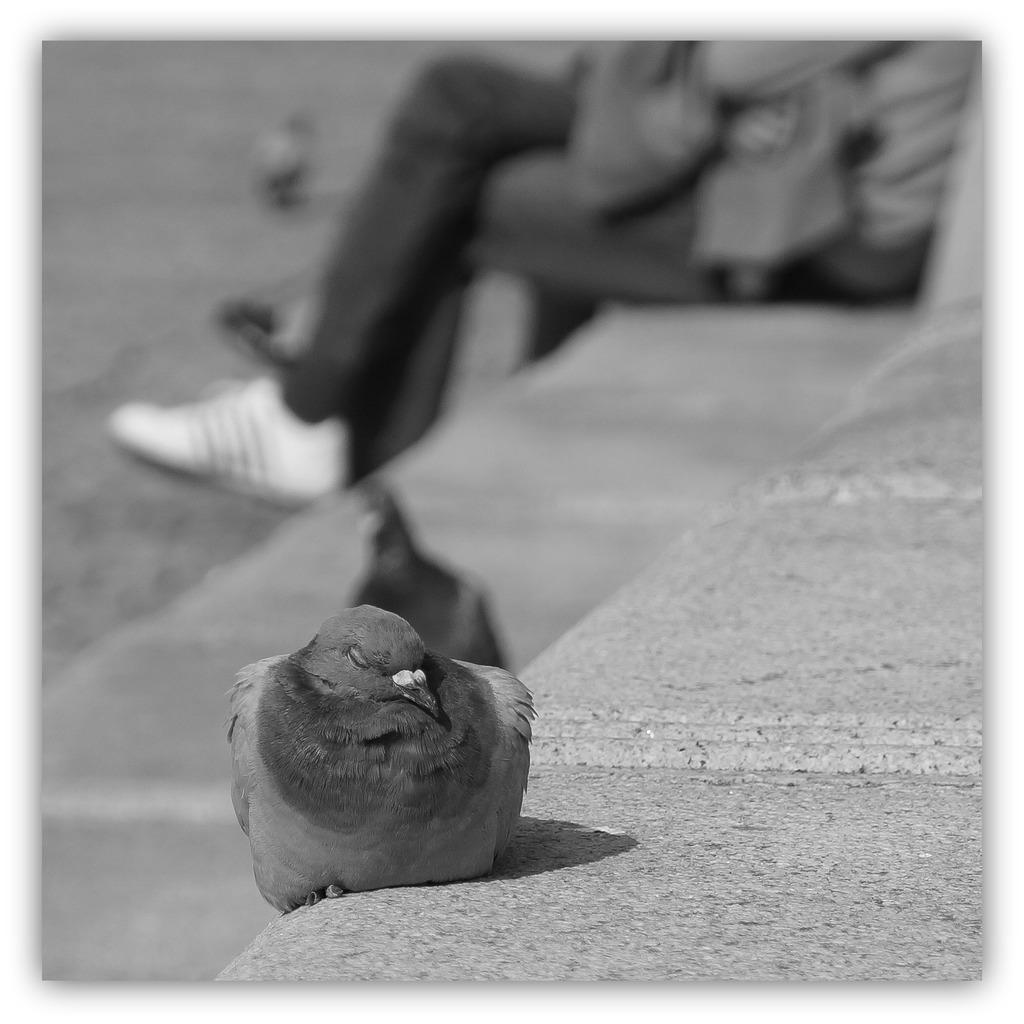What is the color scheme of the image? The image is black and white. What type of animal can be seen in the image? There is a bird in the image. What is the person in the image doing? The person is on the stairs in the image. How many stairs are visible in the image? There are stairs in the image. Where are the other birds located in the image? There are birds on the ground in the image. What is the surface beneath the birds and stairs? There is a ground in the image. How many pockets does the bird have in the image? Birds do not have pockets, so this question cannot be answered. What type of snake can be seen slithering on the stairs in the image? There is no snake present in the image; it only features a bird, a person, stairs, and birds on the ground. 